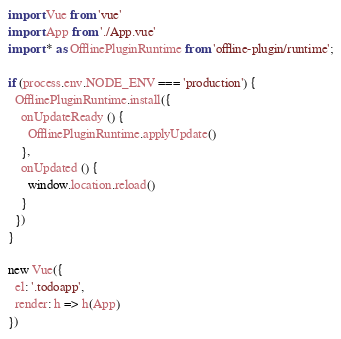Convert code to text. <code><loc_0><loc_0><loc_500><loc_500><_JavaScript_>import Vue from 'vue'
import App from './App.vue'
import * as OfflinePluginRuntime from 'offline-plugin/runtime';

if (process.env.NODE_ENV === 'production') {
  OfflinePluginRuntime.install({
    onUpdateReady () {
      OfflinePluginRuntime.applyUpdate()
    },
    onUpdated () {
      window.location.reload()
    }
  })
}

new Vue({
  el: '.todoapp',
  render: h => h(App)
})
</code> 